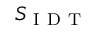<formula> <loc_0><loc_0><loc_500><loc_500>S _ { I D T }</formula> 